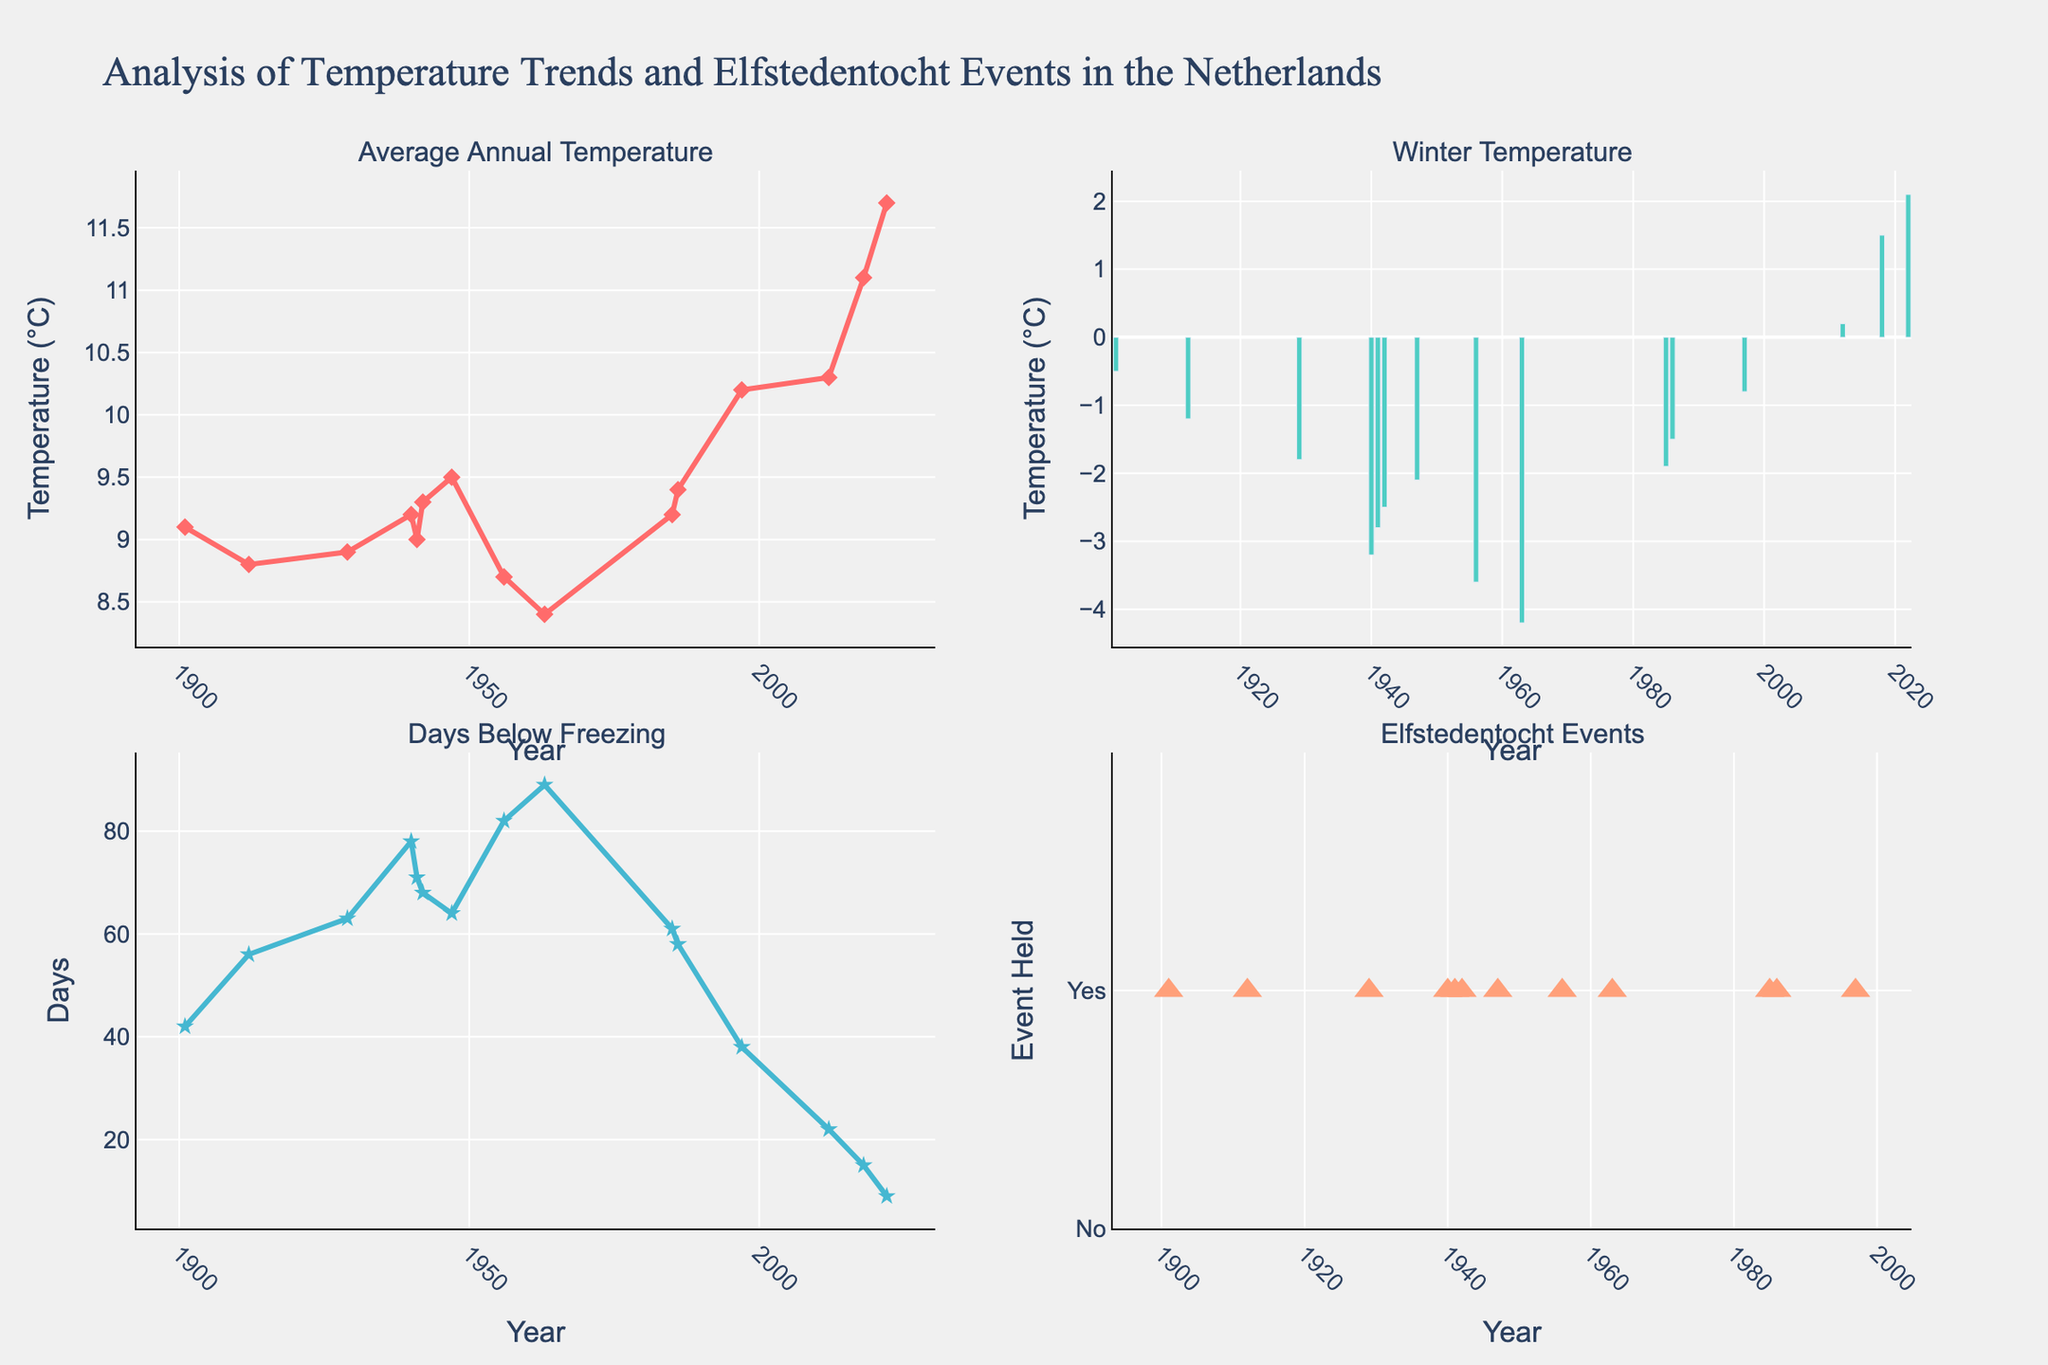What is the title of the figure? The title is displayed at the top of the figure, showing the overall context of the plots.
Answer: Analysis of Temperature Trends and Elfstedentocht Events in the Netherlands What color is used to represent the Average Annual Temperature? The line and markers for Average Annual Temperature are represented using a specific color that stands out in the first subplot.
Answer: Red How many Elfstedentocht events were held in the 20th century? By examining the markers in the fourth plot representing the Elfstedentocht events, one can count the occurrences from 1900 to 1999.
Answer: 10 What is the warmest Winter Temperature recorded in the dataset? Observing the second subplot (Winter Temperature in °C), locate the highest bar among the years.
Answer: 2.1°C How did Days Below Freezing change over the century? Look at the trend line in the third subplot to trace the general pattern of days with temperatures below freezing over the years.
Answer: Decreased In which year was the last Elfstedentocht held according to the plot? On the fourth subplot, find the most recent year with a marker indicating that the event was held.
Answer: 1997 Which year had the maximum number of Days Below Freezing, and how many days were recorded? Inspect the third subplot for the highest data point and count the corresponding days below freezing.
Answer: 1963, 89 days Compare the Average Annual Temperature in 1940 and 1997. Which year was warmer? Locate 1940 and 1997 on the first subplot and compare the height of their markers.
Answer: 1997 What is the general trend of Winter Temperature from 1901 to 2022? By analyzing the bars in the second subplot from beginning to end, note the overall direction of the temperatures.
Answer: Increasing How many days below freezing were recorded in 1985? Find the year 1985 in the third subplot and read off the corresponding number of days below freezing.
Answer: 61 